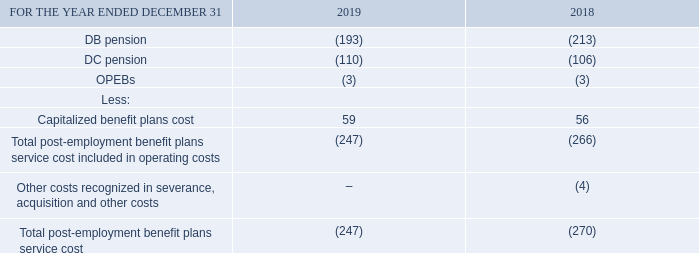Note 24 Post-employment benefit plans
POST-EMPLOYMENT BENEFIT PLANS COST
We provide pension and other benefits for most of our employees. These include DB pension plans, DC pension plans and OPEBs.
We operate our DB and DC pension plans under applicable Canadian and provincial pension legislation, which prescribes minimum and maximum DB funding requirements. Plan assets are held in trust, and the oversight of governance of the plans, including investment decisions, contributions to DB plans and the selection of the DC plans investment options offered to plan participants, lies with the Pension Fund Committee, a committee of our board of directors.
The interest rate risk is managed using a liability matching approach, which reduces the exposure of the DB plans to a mismatch between investment growth and obligation growth.
The longevity risk is managed using a longevity swap, which reduces the exposure of the DB plans to an increase in life expectancy.
COMPONENTS OF POST-EMPLOYMENT BENEFIT PLANS SERVICE COST
How is interest rate risk managed? Using a liability matching approach, which reduces the exposure of the db plans to a mismatch between investment growth and obligation growth. How is longevity risk managed? Using a longevity swap, which reduces the exposure of the db plans to an increase in life expectancy. What are the components for post-employment benefit plans service cost? Db pension, dc pension, opebs. How many post-employment benefit plans are there? DB pension##DC pension##OPEBs
Answer: 3. What is the change in capitalized benefit plans cost in 2019? 59-56
Answer: 3. What is the average total post-employment benefit plans service cost over 2018 and 2019? (-247+(-270))/2
Answer: -258.5. 